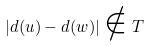<formula> <loc_0><loc_0><loc_500><loc_500>| d ( u ) - d ( w ) | \notin T</formula> 